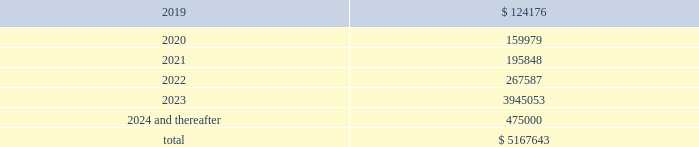Maturity requirements on long-term debt as of december 31 , 2018 by year are as follows ( in thousands ) : years ending december 31 .
Credit facility we are party to a credit facility agreement with bank of america , n.a. , as administrative agent , and a syndicate of financial institutions as lenders and other agents ( as amended from time to time , the 201ccredit facility 201d ) .
As of december 31 , 2018 , the credit facility provided for secured financing comprised of ( i ) a $ 1.5 billion revolving credit facility ( the 201crevolving credit facility 201d ) ; ( ii ) a $ 1.5 billion term loan ( the 201cterm a loan 201d ) , ( iii ) a $ 1.37 billion term loan ( the 201cterm a-2 loan 201d ) , ( iv ) a $ 1.14 billion term loan facility ( the 201cterm b-2 loan 201d ) and ( v ) a $ 500 million term loan ( the 201cterm b-4 loan 201d ) .
Substantially all of the assets of our domestic subsidiaries are pledged as collateral under the credit facility .
The borrowings outstanding under our credit facility as of december 31 , 2018 reflect amounts borrowed for acquisitions and other activities we completed in 2018 , including a reduction to the interest rate margins applicable to our term a loan , term a-2 loan , term b-2 loan and the revolving credit facility , an extension of the maturity dates of the term a loan , term a-2 loan and the revolving credit facility , and an increase in the total financing capacity under the credit facility to approximately $ 5.5 billion in june 2018 .
In october 2018 , we entered into an additional term loan under the credit facility in the amount of $ 500 million ( the 201cterm b-4 loan 201d ) .
We used the proceeds from the term b-4 loan to pay down a portion of the balance outstanding under our revolving credit facility .
The credit facility provides for an interest rate , at our election , of either libor or a base rate , in each case plus a margin .
As of december 31 , 2018 , the interest rates on the term a loan , the term a-2 loan , the term b-2 loan and the term b-4 loan were 4.02% ( 4.02 % ) , 4.01% ( 4.01 % ) , 4.27% ( 4.27 % ) and 4.27% ( 4.27 % ) , respectively , and the interest rate on the revolving credit facility was 3.92% ( 3.92 % ) .
In addition , we are required to pay a quarterly commitment fee with respect to the unused portion of the revolving credit facility at an applicable rate per annum ranging from 0.20% ( 0.20 % ) to 0.30% ( 0.30 % ) depending on our leverage ratio .
The term a loan and the term a-2 loan mature , and the revolving credit facility expires , on january 20 , 2023 .
The term b-2 loan matures on april 22 , 2023 .
The term b-4 loan matures on october 18 , 2025 .
The term a loan and term a-2 loan principal amounts must each be repaid in quarterly installments in the amount of 0.625% ( 0.625 % ) of principal through june 2019 , increasing to 1.25% ( 1.25 % ) of principal through june 2021 , increasing to 1.875% ( 1.875 % ) of principal through june 2022 and increasing to 2.50% ( 2.50 % ) of principal through december 2022 , with the remaining principal balance due upon maturity in january 2023 .
The term b-2 loan principal must be repaid in quarterly installments in the amount of 0.25% ( 0.25 % ) of principal through march 2023 , with the remaining principal balance due upon maturity in april 2023 .
The term b-4 loan principal must be repaid in quarterly installments in the amount of 0.25% ( 0.25 % ) of principal through september 2025 , with the remaining principal balance due upon maturity in october 2025 .
We may issue standby letters of credit of up to $ 100 million in the aggregate under the revolving credit facility .
Outstanding letters of credit under the revolving credit facility reduce the amount of borrowings available to us .
Borrowings available to us under the revolving credit facility are further limited by the covenants described below under 201ccompliance with covenants . 201d the total available commitments under the revolving credit facility at december 31 , 2018 were $ 783.6 million .
Global payments inc .
| 2018 form 10-k annual report 2013 85 .
What portion of the total outstanding long-term debt is included in the current liabilities section as of december 31 , 2018? 
Computations: (124176 / 5167643)
Answer: 0.02403. 